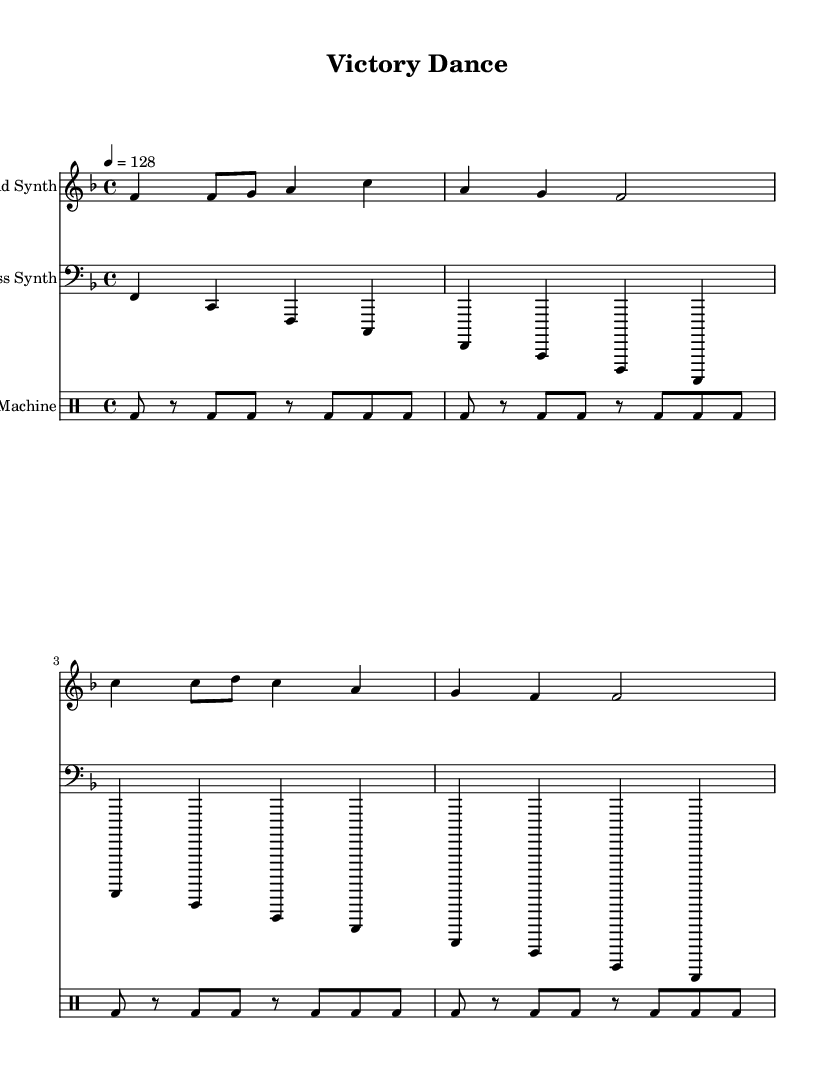What is the key signature of this music? The key signature is F major, which has one flat (B flat). This can be determined by observing the key signature notated at the beginning of the staff.
Answer: F major What is the time signature of this music? The time signature is 4/4, indicated at the beginning of the score. This means there are four beats in each measure and a quarter note receives one beat.
Answer: 4/4 What is the tempo marking for this piece? The tempo marking is 128 beats per minute, indicated by the tempo instruction at the start of the score following the quarter note symbol.
Answer: 128 How many measures are in the lead synth part? The lead synth part consists of 4 measures, which can be counted by checking the bars (vertical lines) dividing the staff into segments in the notation.
Answer: 4 What type of percussion is used in the drum part? The percussion used is a bass drum (bd), as indicated in the drum staff where "bd" is notated in the drummode section.
Answer: Bass drum How many different parts are there in this sheet music? There are three distinct parts: lead synth, bass synth, and drum machine. Each part is presented as a separate staff in the score layout.
Answer: Three What is notable about the bass synth's rhythmic pattern? The bass synth has a consistent alternating pattern between two notes (F and C) in each measure, highlighting a repetitive loop commonly found in electronic music.
Answer: Repetitive loop 